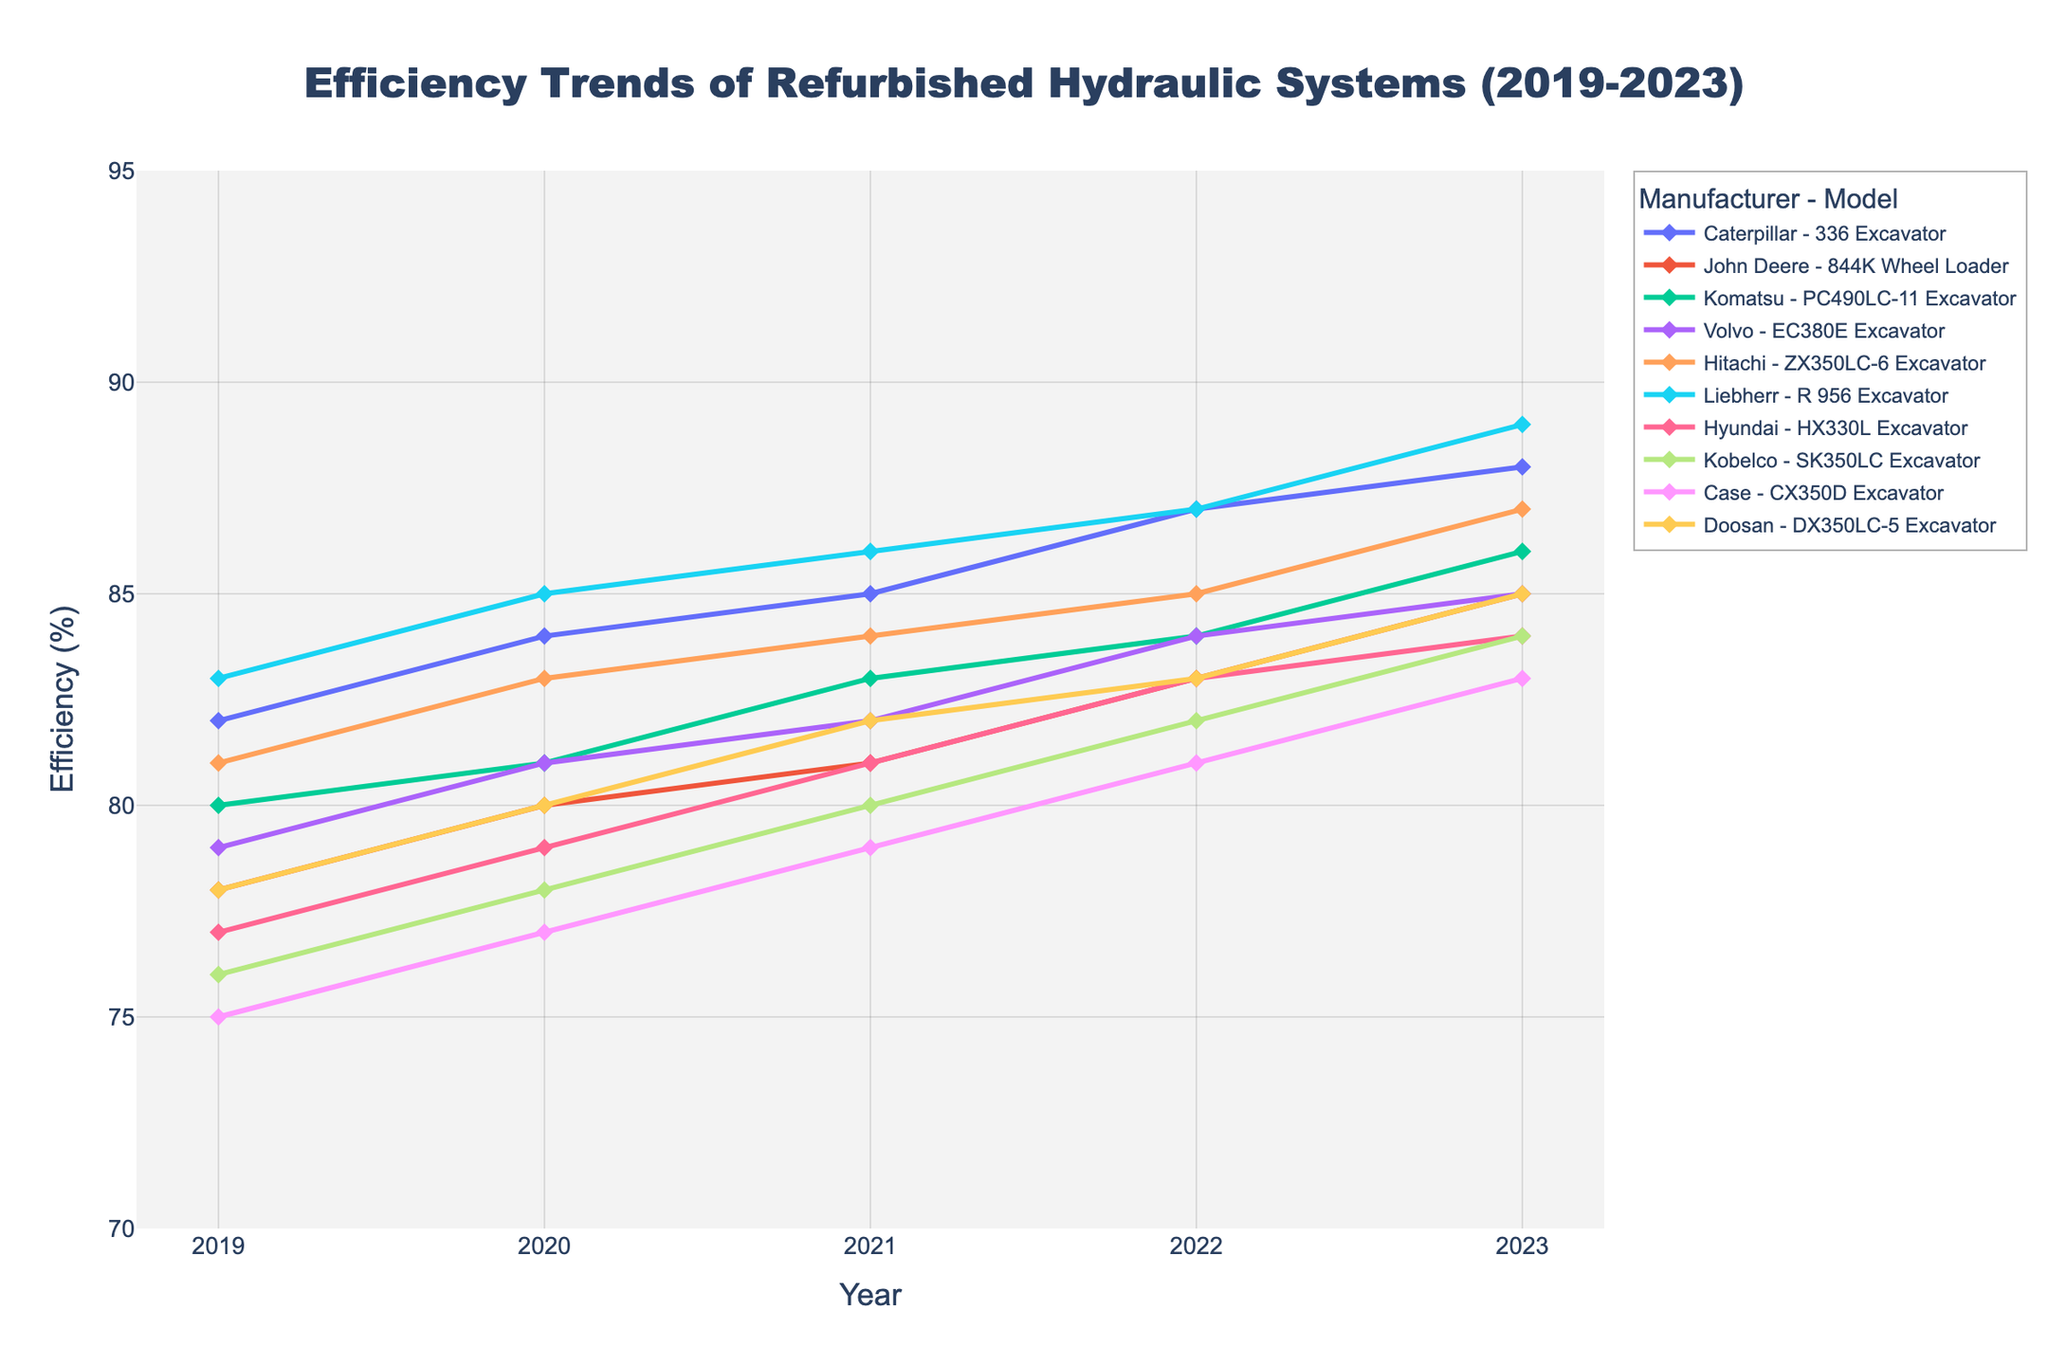Which manufacturer had the highest efficiency in 2023? To find the manufacturer with the highest efficiency in 2023, look at the '2023' data points on the Y-axis and identify the highest point. Correspond it to the manufacturer.
Answer: Liebherr Which model shows the least improvement in efficiency from 2019 to 2023? Calculate the difference between the 2023 and 2019 efficiency values for each model and identify the smallest positive change.
Answer: Case CX350D Excavator How many models improved their efficiency by at least 7% from 2019 to 2023? Calculate the efficiency difference between 2023 and 2019 for each model and count the number of differences that are 7% or more.
Answer: 2 Which model had the second highest efficiency improvement between 2019 and 2023? Calculate the efficiency improvement (difference between 2023 and 2019 values) for all models, sort them, and identify the one with the second highest improvement.
Answer: Hitachi ZX350LC-6 Excavator By how many percentage points did Volvo's EC380E Excavator improve from 2019 to 2022? Check the efficiency values for Volvo EC380E Excavator in 2019 and 2022, then subtract the 2019 value from the 2022 value to find the improvement.
Answer: 5 Which manufacturer had the most consistent year-over-year improvement from 2019 to 2023? Look at the efficiency values for each manufacturer’s model year-by-year, calculate the differences, and identify the manufacturer with the smallest variance in improvements.
Answer: Liebherr What is the average efficiency of the Komatsu PC490LC-11 Excavator over the years 2019 to 2023? Add the efficiency values from 2019 to 2023 for the Komatsu PC490LC-11 Excavator and divide by the number of years. (80 + 81 + 83 + 84 + 86 = 414; 414 / 5 = 82.8)
Answer: 82.8 Did any models decrease in efficiency in any year between 2019 and 2023? Check each model’s efficiency trend on the plot to see if any year-to-year values drop (i.e., if a later year's value is less than the previous year's value).
Answer: No 